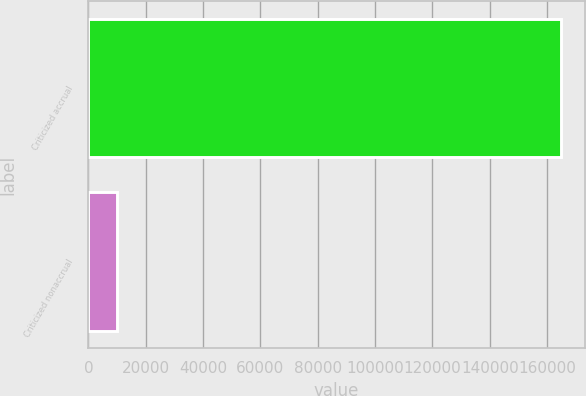Convert chart. <chart><loc_0><loc_0><loc_500><loc_500><bar_chart><fcel>Criticized accrual<fcel>Criticized nonaccrual<nl><fcel>164812<fcel>10088<nl></chart> 